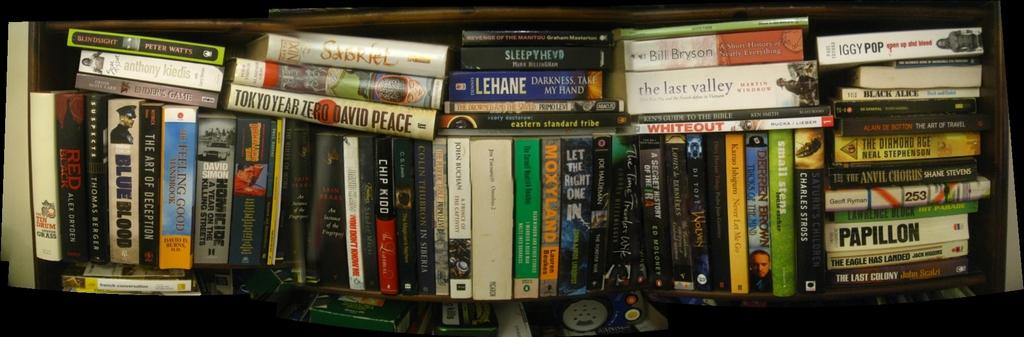What objects can be seen in the image? There are books in the image. Where are the books located? The books are on a shelf. What can be seen on the book covers? There is writing on the book covers. What type of beef is being cooked on the stove in the image? There is no stove or beef present in the image; it only features books on a shelf with writing on their covers. 